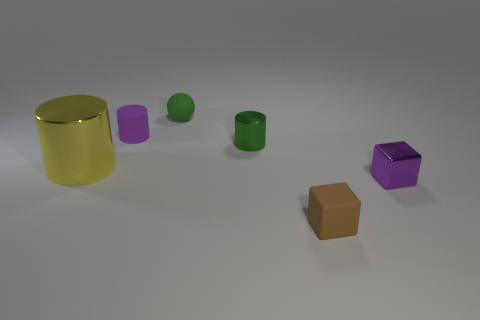Is the number of large yellow cylinders that are behind the green rubber sphere less than the number of tiny matte balls?
Keep it short and to the point. Yes. The tiny object in front of the purple object in front of the metallic object that is left of the tiny purple matte object is made of what material?
Your answer should be very brief. Rubber. Are there more brown rubber blocks left of the small metallic cylinder than large yellow metallic cylinders that are on the right side of the yellow thing?
Your answer should be very brief. No. How many shiny objects are either brown cylinders or tiny green things?
Provide a short and direct response. 1. There is a small thing that is the same color as the tiny ball; what is its shape?
Give a very brief answer. Cylinder. There is a block in front of the purple metal thing; what is it made of?
Your answer should be very brief. Rubber. What number of things are either tiny purple things or purple things behind the small green metal cylinder?
Provide a succinct answer. 2. There is a brown matte thing that is the same size as the rubber ball; what is its shape?
Ensure brevity in your answer.  Cube. How many tiny objects have the same color as the small shiny block?
Make the answer very short. 1. Does the green object in front of the purple cylinder have the same material as the purple cylinder?
Your answer should be very brief. No. 